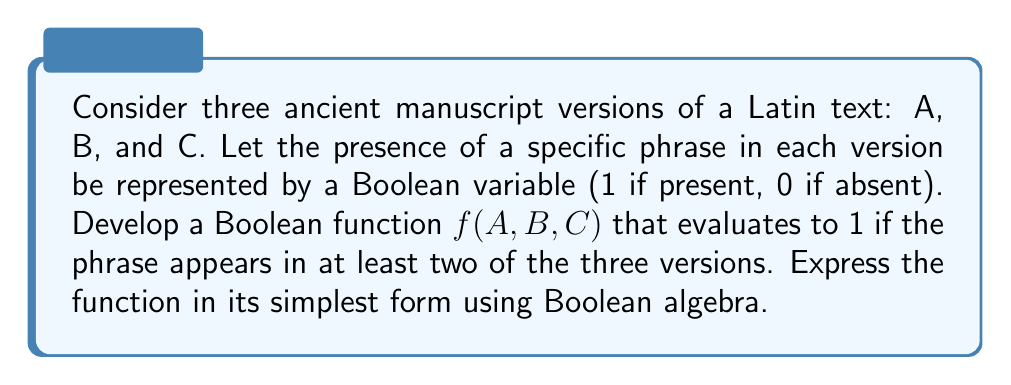Solve this math problem. To develop the Boolean function, we'll follow these steps:

1) First, let's consider when the function should evaluate to 1:
   - When A and B contain the phrase (regardless of C)
   - When A and C contain the phrase (regardless of B)
   - When B and C contain the phrase (regardless of A)

2) We can express this using Boolean algebra as:
   $f(A,B,C) = AB + AC + BC$

3) This expression is already in its simplest form, known as the Sum of Products (SOP) form. However, we can verify this using Boolean algebra laws:

4) Using the distributive law, we could expand this to:
   $f(A,B,C) = AB(C + C') + AC(B + B') + BC(A + A')$

5) Simplify using the identity $X + X' = 1$:
   $f(A,B,C) = AB + AC + BC$

6) This confirms that our original expression is indeed in its simplest form.

7) We can also interpret this function logically: it will return 1 (true) if at least two of the input variables are 1, which matches our requirement of the phrase appearing in at least two versions.
Answer: $f(A,B,C) = AB + AC + BC$ 